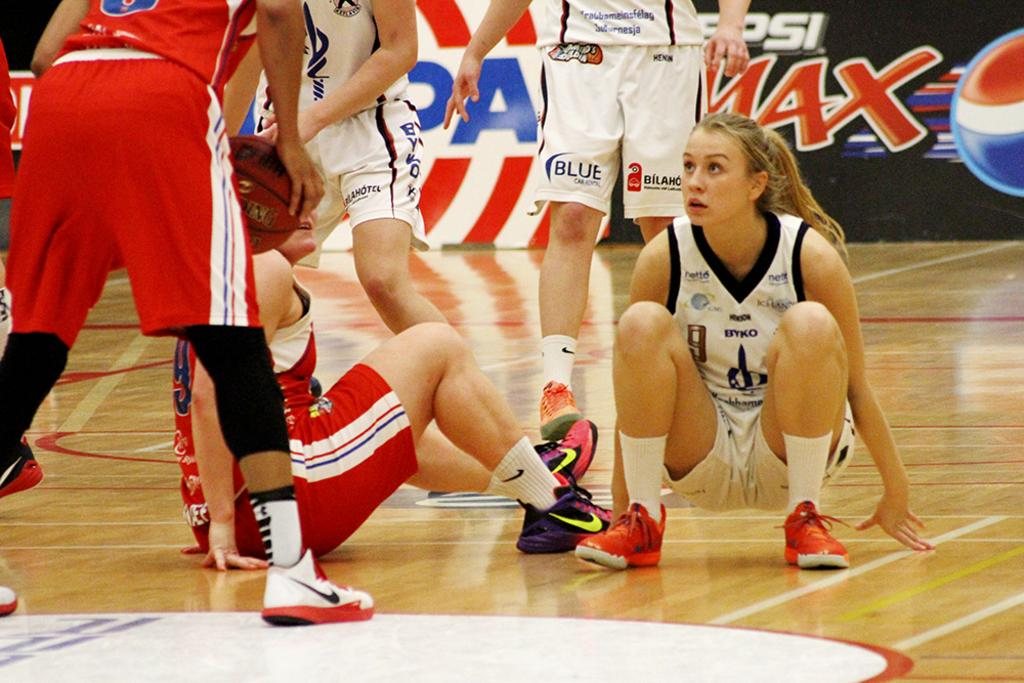<image>
Share a concise interpretation of the image provided. A girls basketball court with an ad for Pepsi Max in the background 